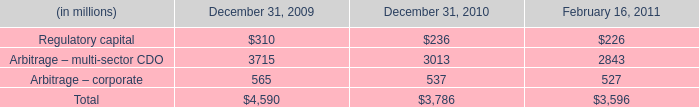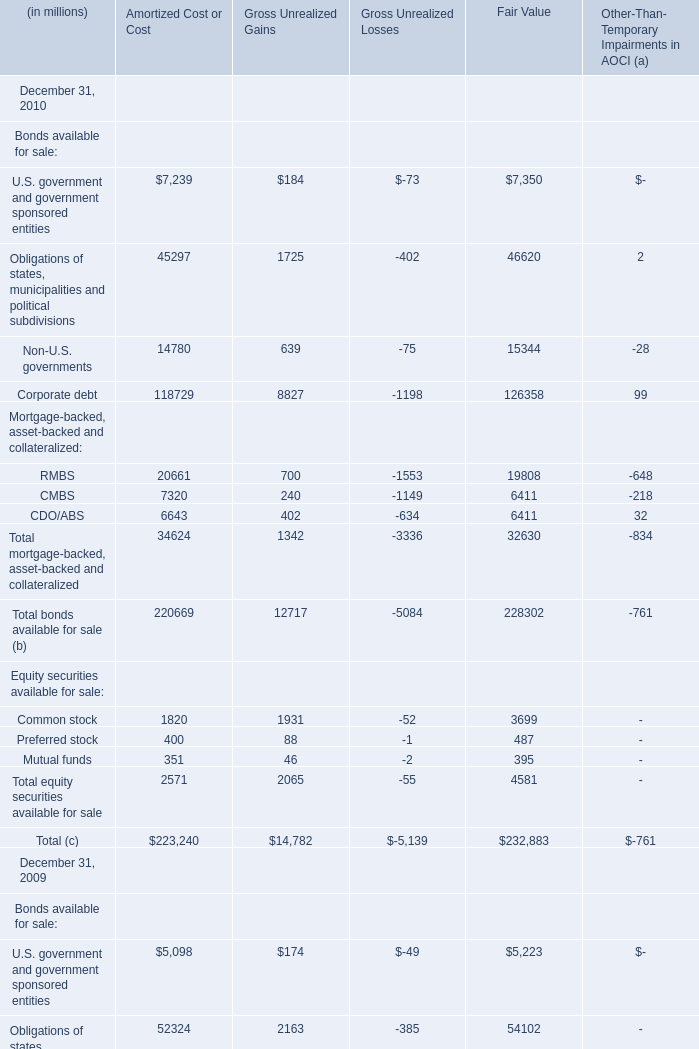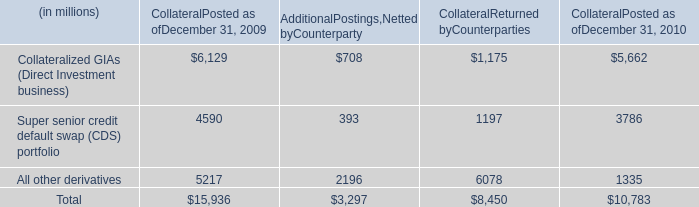What is the difference between the greatest Bonds available for sale of Amortized Cost or Cost in 2010 and 2009？ (in millions) 
Computations: (118729 - 185188)
Answer: -66459.0. 